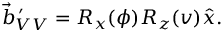<formula> <loc_0><loc_0><loc_500><loc_500>\vec { b } _ { V V } ^ { \, \prime } = R _ { x } ( \phi ) R _ { z } ( v ) \hat { x } .</formula> 